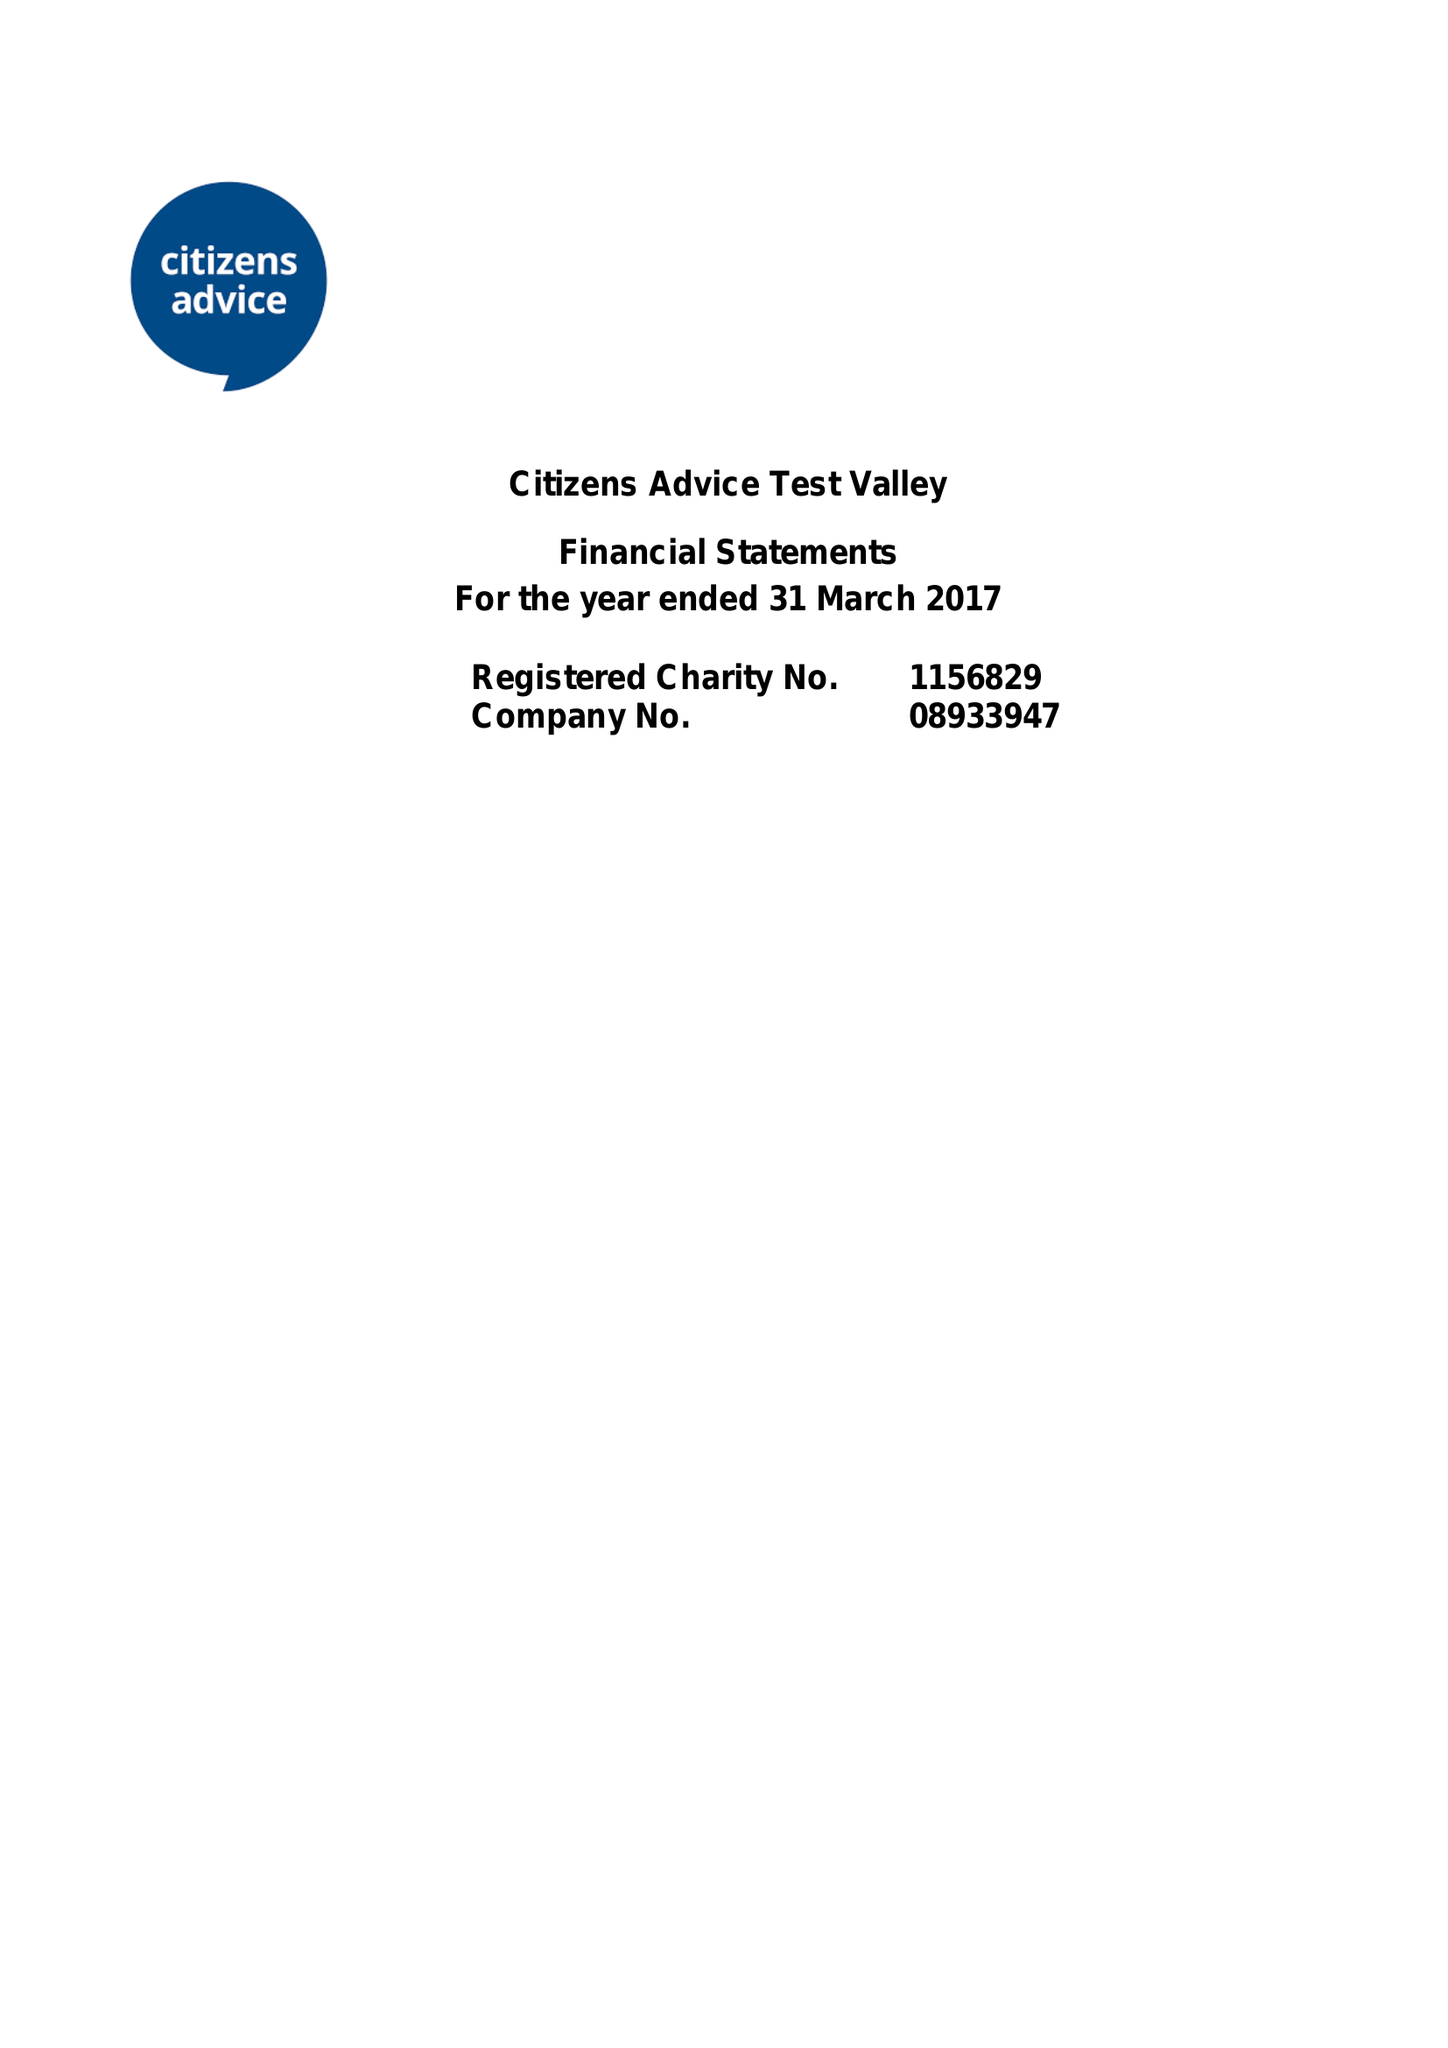What is the value for the charity_number?
Answer the question using a single word or phrase. 1156829 